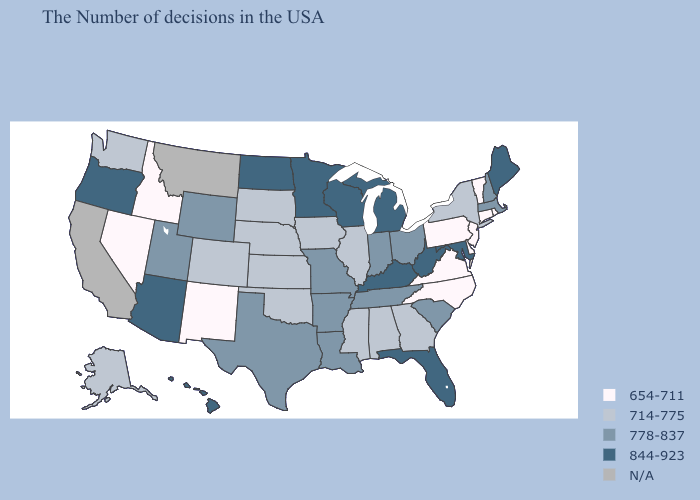What is the lowest value in the West?
Answer briefly. 654-711. Among the states that border New York , does Massachusetts have the lowest value?
Short answer required. No. Name the states that have a value in the range N/A?
Short answer required. Montana, California. What is the lowest value in states that border Indiana?
Be succinct. 714-775. What is the value of Vermont?
Quick response, please. 654-711. What is the value of Arizona?
Give a very brief answer. 844-923. Does the first symbol in the legend represent the smallest category?
Be succinct. Yes. Does Delaware have the highest value in the USA?
Concise answer only. No. Does Maryland have the highest value in the USA?
Write a very short answer. Yes. Name the states that have a value in the range 844-923?
Keep it brief. Maine, Maryland, West Virginia, Florida, Michigan, Kentucky, Wisconsin, Minnesota, North Dakota, Arizona, Oregon, Hawaii. Name the states that have a value in the range 778-837?
Quick response, please. Massachusetts, New Hampshire, South Carolina, Ohio, Indiana, Tennessee, Louisiana, Missouri, Arkansas, Texas, Wyoming, Utah. Name the states that have a value in the range N/A?
Answer briefly. Montana, California. What is the value of New Jersey?
Write a very short answer. 654-711. What is the highest value in states that border South Dakota?
Keep it brief. 844-923. Name the states that have a value in the range 844-923?
Short answer required. Maine, Maryland, West Virginia, Florida, Michigan, Kentucky, Wisconsin, Minnesota, North Dakota, Arizona, Oregon, Hawaii. 